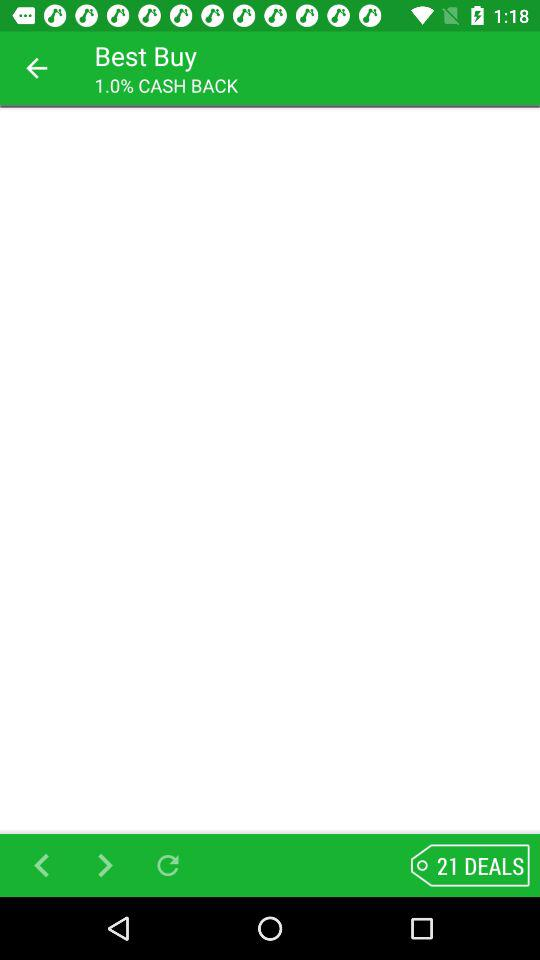What is the total number of deals shown on the screen? The total number of deals shown are 21. 